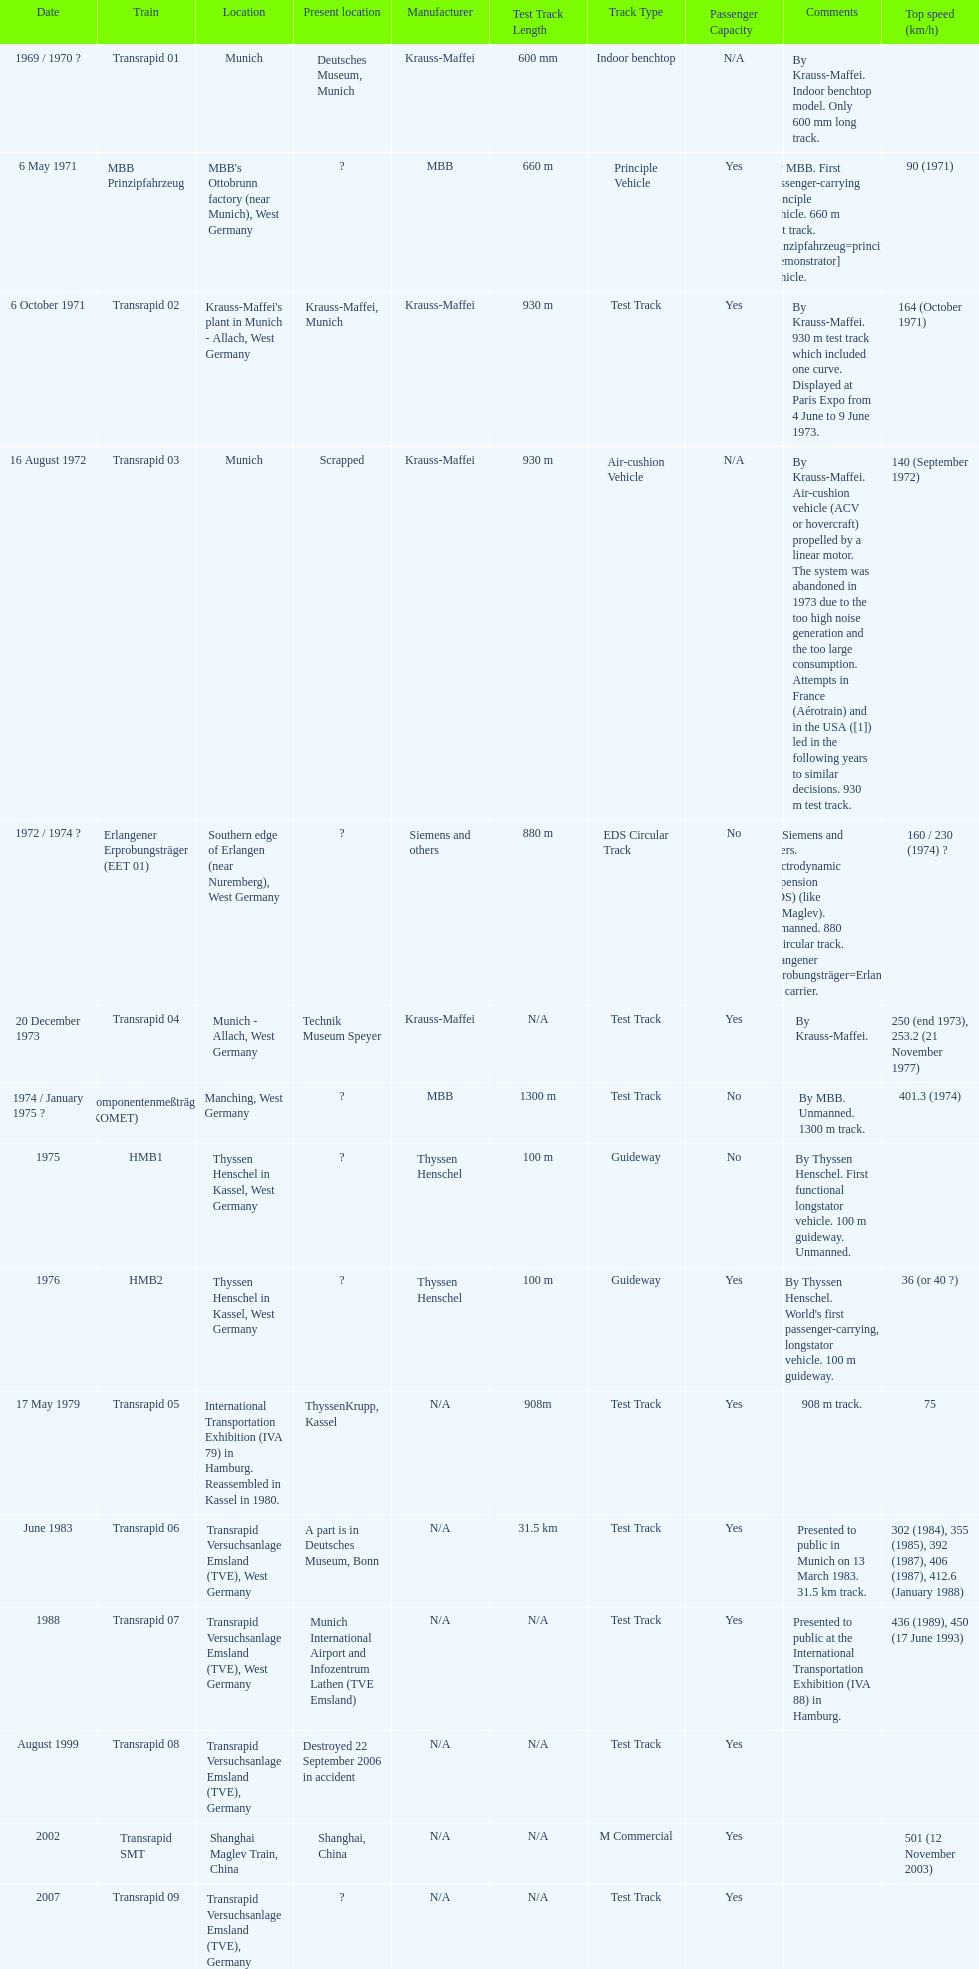Excessive noise production and substantial consumption resulted in which train being discarded? Transrapid 03. 